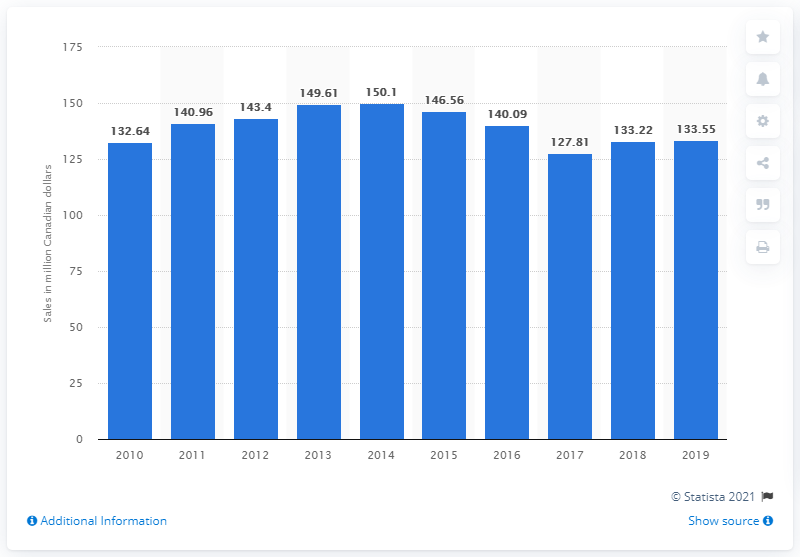Identify some key points in this picture. In 2019, the amount of dollars worth of cut flowers sold in Canada was 133.55. 